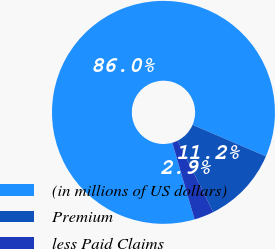Convert chart. <chart><loc_0><loc_0><loc_500><loc_500><pie_chart><fcel>(in millions of US dollars)<fcel>Premium<fcel>less Paid Claims<nl><fcel>85.96%<fcel>11.18%<fcel>2.87%<nl></chart> 